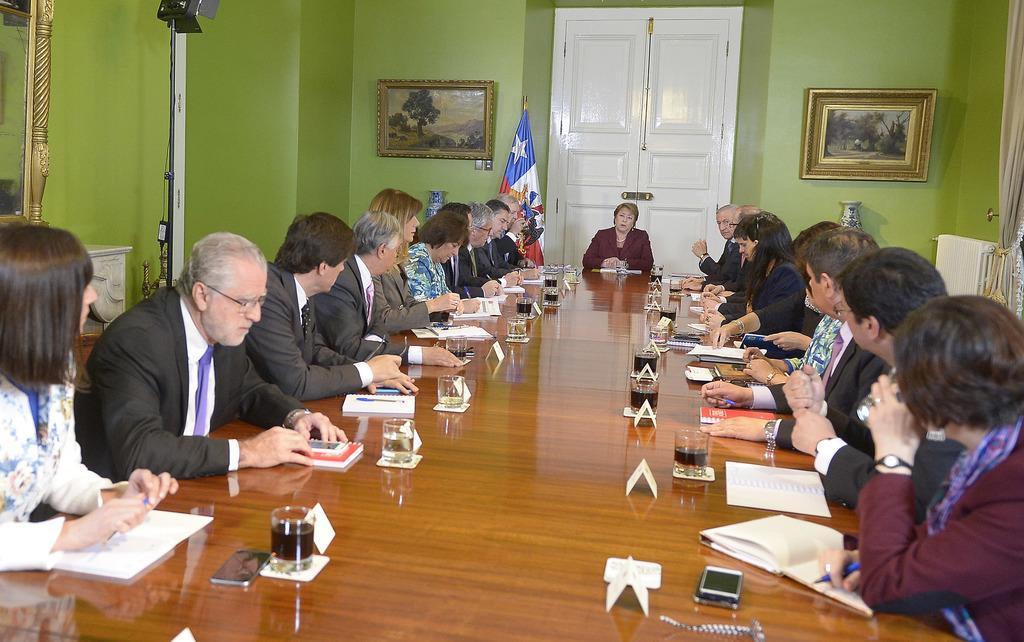Could you give a brief overview of what you see in this image? In this image i can see a group of people sitting on chair there are few books, glasses, mobile, pen on a table at the back ground i can see door, flag, frame on a wall. 